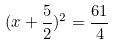Convert formula to latex. <formula><loc_0><loc_0><loc_500><loc_500>( x + \frac { 5 } { 2 } ) ^ { 2 } = \frac { 6 1 } { 4 }</formula> 